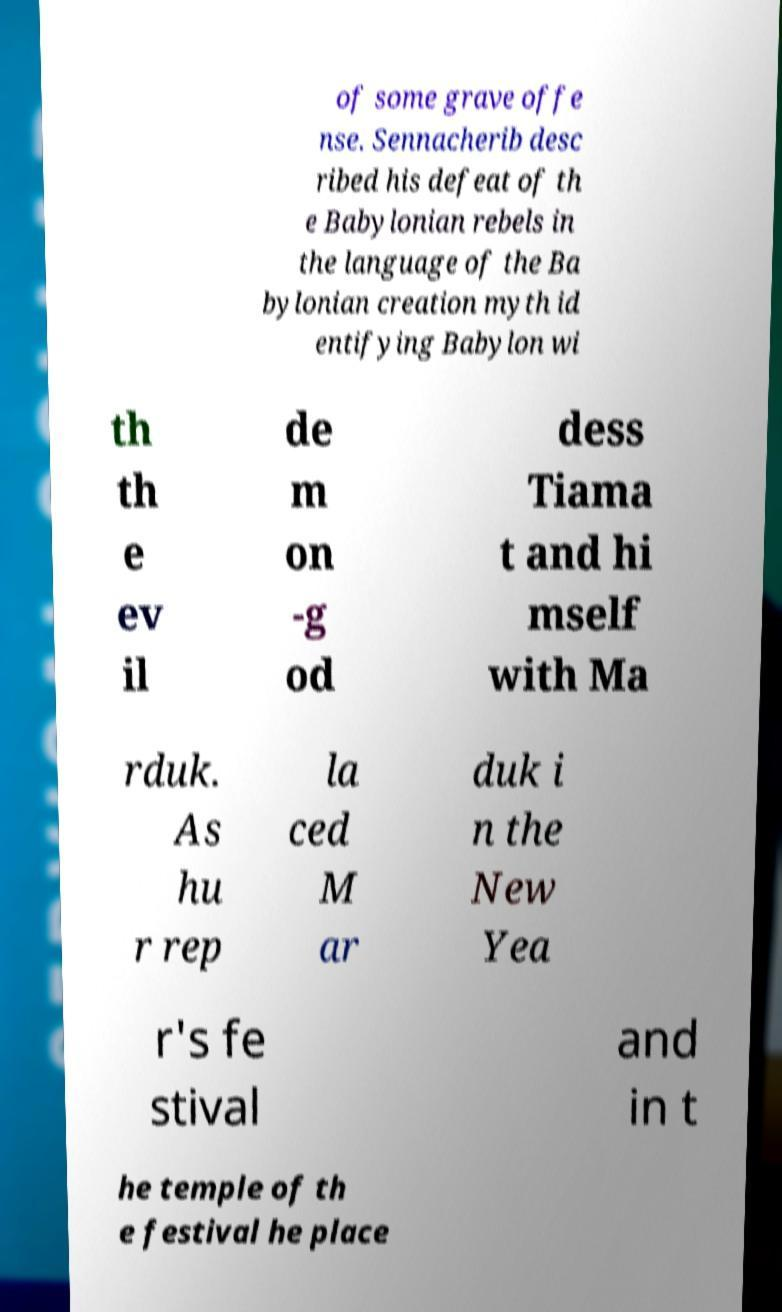I need the written content from this picture converted into text. Can you do that? of some grave offe nse. Sennacherib desc ribed his defeat of th e Babylonian rebels in the language of the Ba bylonian creation myth id entifying Babylon wi th th e ev il de m on -g od dess Tiama t and hi mself with Ma rduk. As hu r rep la ced M ar duk i n the New Yea r's fe stival and in t he temple of th e festival he place 